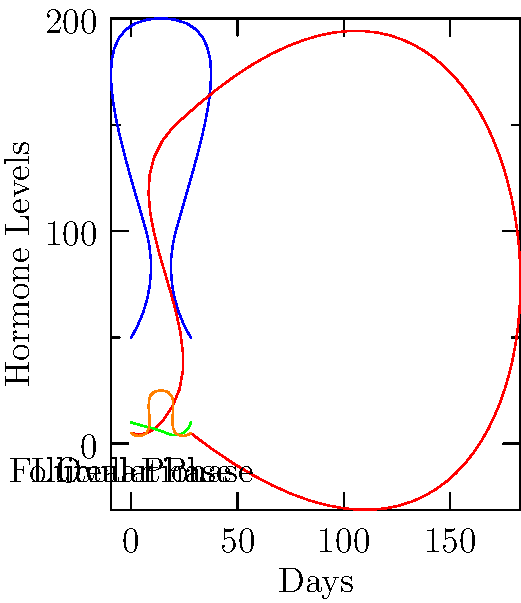Based on the hormonal changes depicted in the graph, which hormone shows the most significant spike during ovulation, and how does this relate to the release of an egg from the ovary? To answer this question, let's analyze the graph step-by-step:

1. The graph shows the levels of four hormones (Estrogen, Progesterone, FSH, and LH) over the course of a 28-day menstrual cycle.

2. The cycle is divided into three phases: Follicular Phase, Ovulation, and Luteal Phase.

3. Looking at the hormone levels during ovulation (around day 14):
   - Estrogen (blue) shows a peak but not a sharp spike
   - Progesterone (red) begins to rise but doesn't spike
   - FSH (green) shows a small increase
   - LH (orange) displays a dramatic spike

4. The hormone with the most significant spike during ovulation is Luteinizing Hormone (LH).

5. This LH surge is crucial for ovulation because:
   - It triggers the final maturation of the egg
   - It causes the rupture of the follicle
   - It leads to the release of the mature egg from the ovary

6. The LH surge typically occurs 24-36 hours before ovulation, preparing the egg for potential fertilization.

7. This spike in LH is a key indicator used in fertility tracking and ovulation prediction methods.
Answer: LH (Luteinizing Hormone) shows the most significant spike, triggering egg release. 